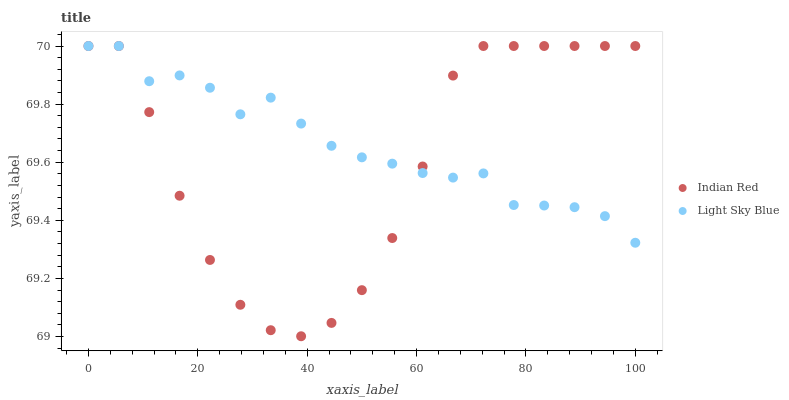Does Indian Red have the minimum area under the curve?
Answer yes or no. Yes. Does Light Sky Blue have the maximum area under the curve?
Answer yes or no. Yes. Does Indian Red have the maximum area under the curve?
Answer yes or no. No. Is Light Sky Blue the smoothest?
Answer yes or no. Yes. Is Indian Red the roughest?
Answer yes or no. Yes. Is Indian Red the smoothest?
Answer yes or no. No. Does Indian Red have the lowest value?
Answer yes or no. Yes. Does Indian Red have the highest value?
Answer yes or no. Yes. Does Light Sky Blue intersect Indian Red?
Answer yes or no. Yes. Is Light Sky Blue less than Indian Red?
Answer yes or no. No. Is Light Sky Blue greater than Indian Red?
Answer yes or no. No. 